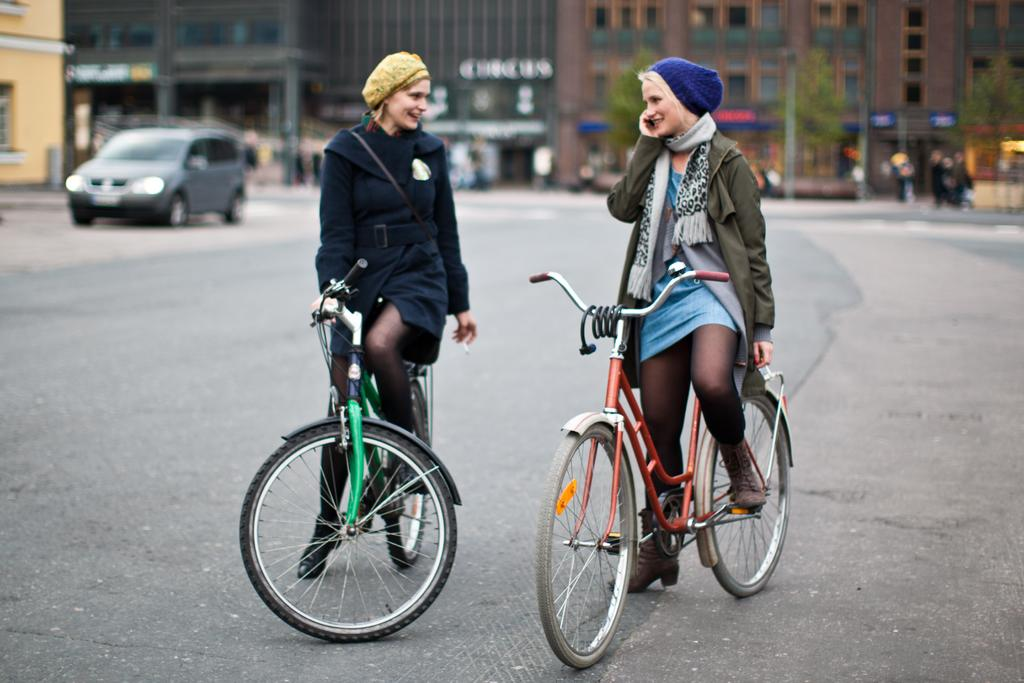How many girls are in the image? There are two girls in the image. What are the girls doing in the image? The girls are standing on a bicycle. Where is the bicycle located in the image? The bicycle is on the road. What can be seen in the background of the image? There are vehicles and buildings in the background of the image. What type of disease can be seen affecting the girls in the image? There is no indication of any disease affecting the girls in the image. What place is the image taken from? The provided facts do not give any information about the location or place where the image was taken. 